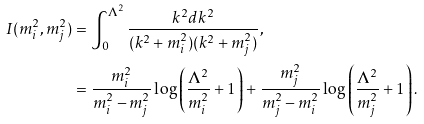Convert formula to latex. <formula><loc_0><loc_0><loc_500><loc_500>I ( m _ { i } ^ { 2 } , m _ { j } ^ { 2 } ) & = \int _ { 0 } ^ { \Lambda ^ { 2 } } \frac { k ^ { 2 } d k ^ { 2 } } { ( k ^ { 2 } + m _ { i } ^ { 2 } ) ( k ^ { 2 } + m _ { j } ^ { 2 } ) } , \\ & = \frac { m _ { i } ^ { 2 } } { m _ { i } ^ { 2 } - m _ { j } ^ { 2 } } \log \left ( \frac { \Lambda ^ { 2 } } { m _ { i } ^ { 2 } } + 1 \right ) + \frac { m _ { j } ^ { 2 } } { m _ { j } ^ { 2 } - m _ { i } ^ { 2 } } \log \left ( \frac { \Lambda ^ { 2 } } { m _ { j } ^ { 2 } } + 1 \right ) .</formula> 